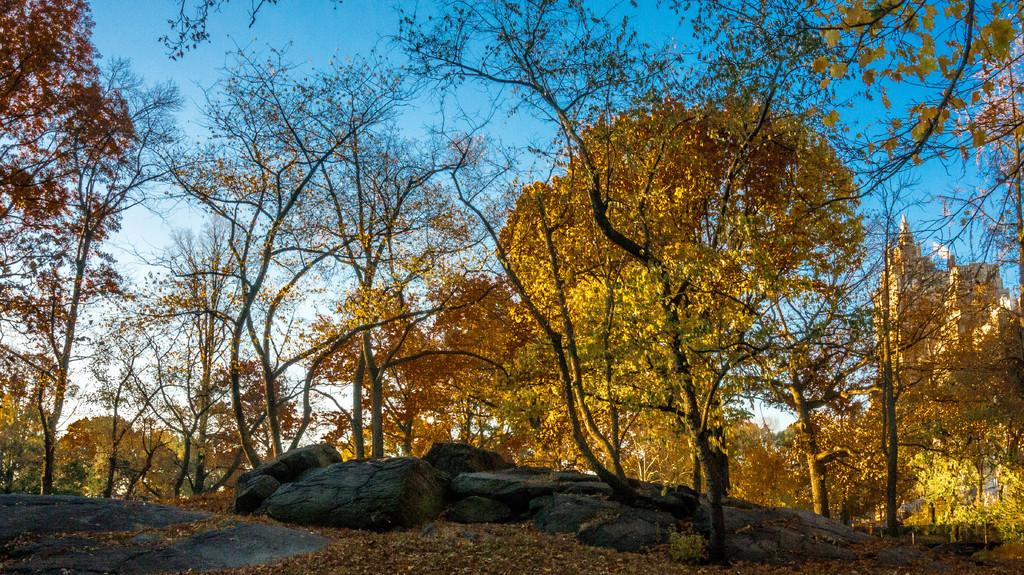What type of vegetation can be seen in the image? There are trees in the image. What color are the flowers in the image? There are yellow flowers in the image. What type of natural formation is present in the image? There are rocks in the image. What is the color of the sky in the image? The sky is blue and white in color. Where is the goat located in the image? There is no goat present in the image. What type of weapon is visible in the image? There is no weapon, such as a cannon, present in the image. 